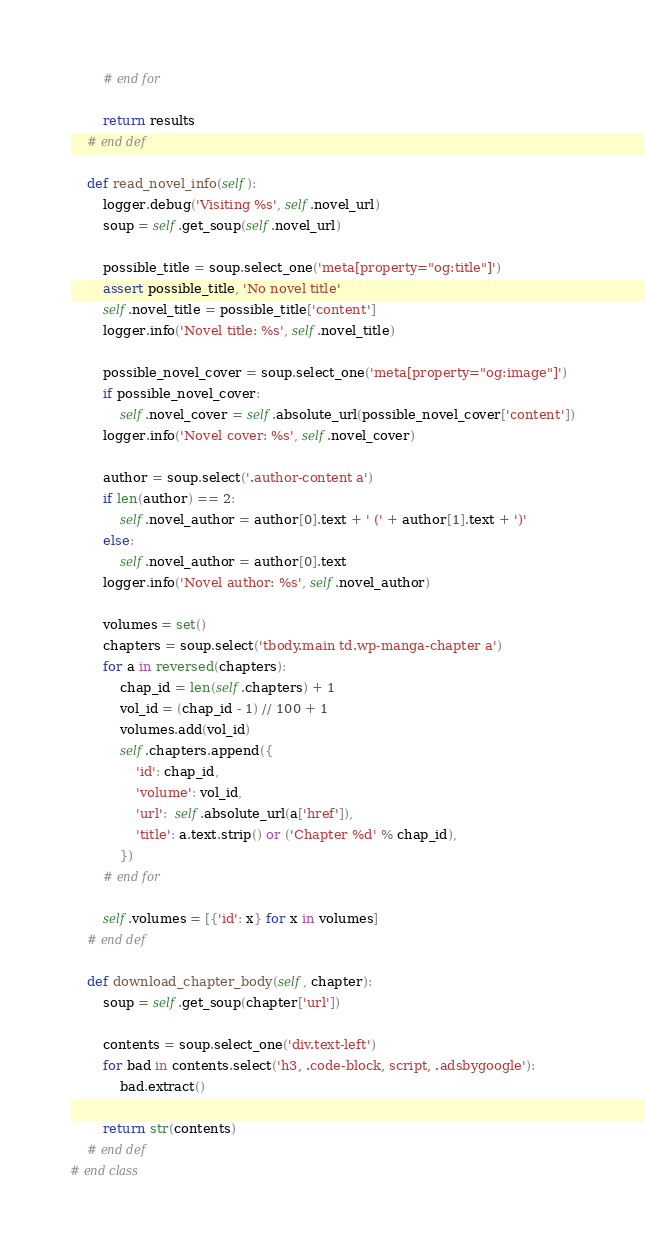Convert code to text. <code><loc_0><loc_0><loc_500><loc_500><_Python_>        # end for

        return results
    # end def

    def read_novel_info(self):
        logger.debug('Visiting %s', self.novel_url)
        soup = self.get_soup(self.novel_url)

        possible_title = soup.select_one('meta[property="og:title"]')
        assert possible_title, 'No novel title'
        self.novel_title = possible_title['content']
        logger.info('Novel title: %s', self.novel_title)

        possible_novel_cover = soup.select_one('meta[property="og:image"]')
        if possible_novel_cover:
            self.novel_cover = self.absolute_url(possible_novel_cover['content'])
        logger.info('Novel cover: %s', self.novel_cover)

        author = soup.select('.author-content a')
        if len(author) == 2:
            self.novel_author = author[0].text + ' (' + author[1].text + ')'
        else:
            self.novel_author = author[0].text
        logger.info('Novel author: %s', self.novel_author)

        volumes = set()
        chapters = soup.select('tbody.main td.wp-manga-chapter a')
        for a in reversed(chapters):
            chap_id = len(self.chapters) + 1
            vol_id = (chap_id - 1) // 100 + 1
            volumes.add(vol_id)
            self.chapters.append({
                'id': chap_id,
                'volume': vol_id,
                'url':  self.absolute_url(a['href']),
                'title': a.text.strip() or ('Chapter %d' % chap_id),
            })
        # end for

        self.volumes = [{'id': x} for x in volumes]
    # end def

    def download_chapter_body(self, chapter):
        soup = self.get_soup(chapter['url'])

        contents = soup.select_one('div.text-left')
        for bad in contents.select('h3, .code-block, script, .adsbygoogle'):
            bad.extract()

        return str(contents)
    # end def
# end class</code> 